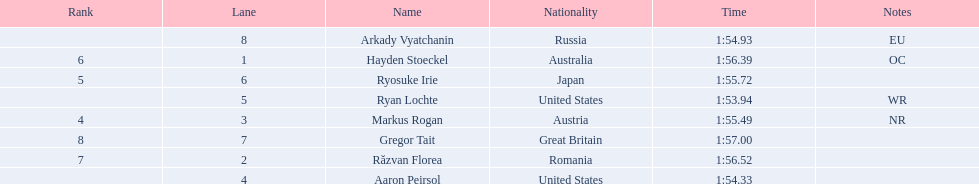Which country had the most medals in the competition? United States. Parse the full table. {'header': ['Rank', 'Lane', 'Name', 'Nationality', 'Time', 'Notes'], 'rows': [['', '8', 'Arkady Vyatchanin', 'Russia', '1:54.93', 'EU'], ['6', '1', 'Hayden Stoeckel', 'Australia', '1:56.39', 'OC'], ['5', '6', 'Ryosuke Irie', 'Japan', '1:55.72', ''], ['', '5', 'Ryan Lochte', 'United States', '1:53.94', 'WR'], ['4', '3', 'Markus Rogan', 'Austria', '1:55.49', 'NR'], ['8', '7', 'Gregor Tait', 'Great Britain', '1:57.00', ''], ['7', '2', 'Răzvan Florea', 'Romania', '1:56.52', ''], ['', '4', 'Aaron Peirsol', 'United States', '1:54.33', '']]} 